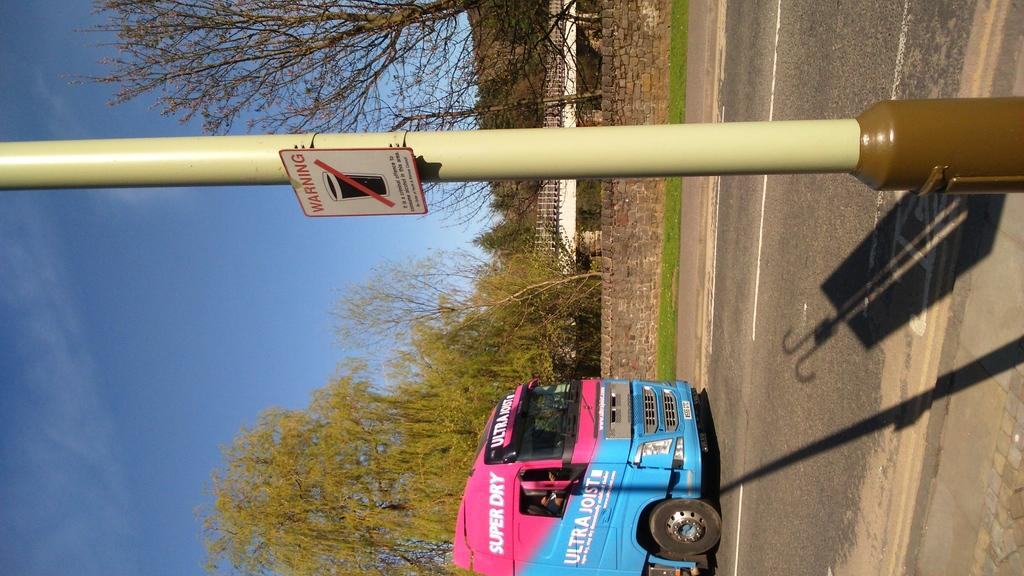<image>
Present a compact description of the photo's key features. A blue and pink van has Super Dry in white letters. 